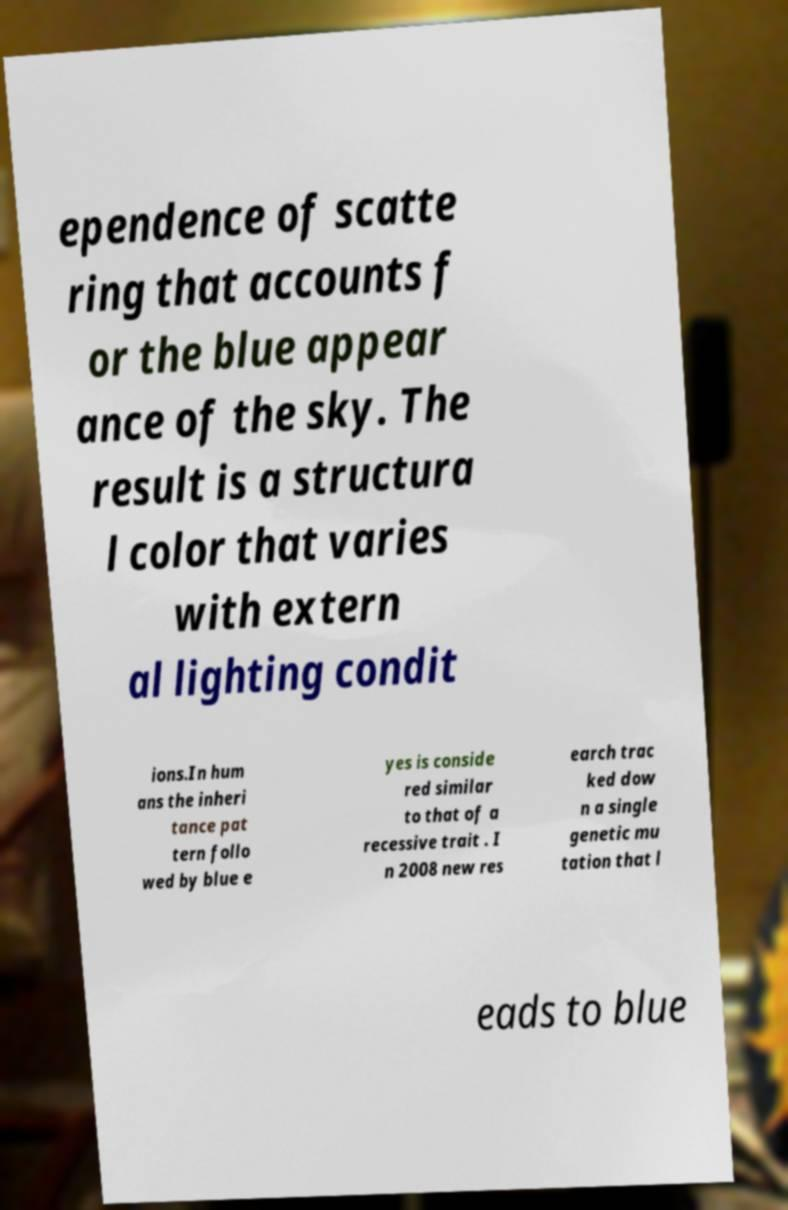I need the written content from this picture converted into text. Can you do that? ependence of scatte ring that accounts f or the blue appear ance of the sky. The result is a structura l color that varies with extern al lighting condit ions.In hum ans the inheri tance pat tern follo wed by blue e yes is conside red similar to that of a recessive trait . I n 2008 new res earch trac ked dow n a single genetic mu tation that l eads to blue 